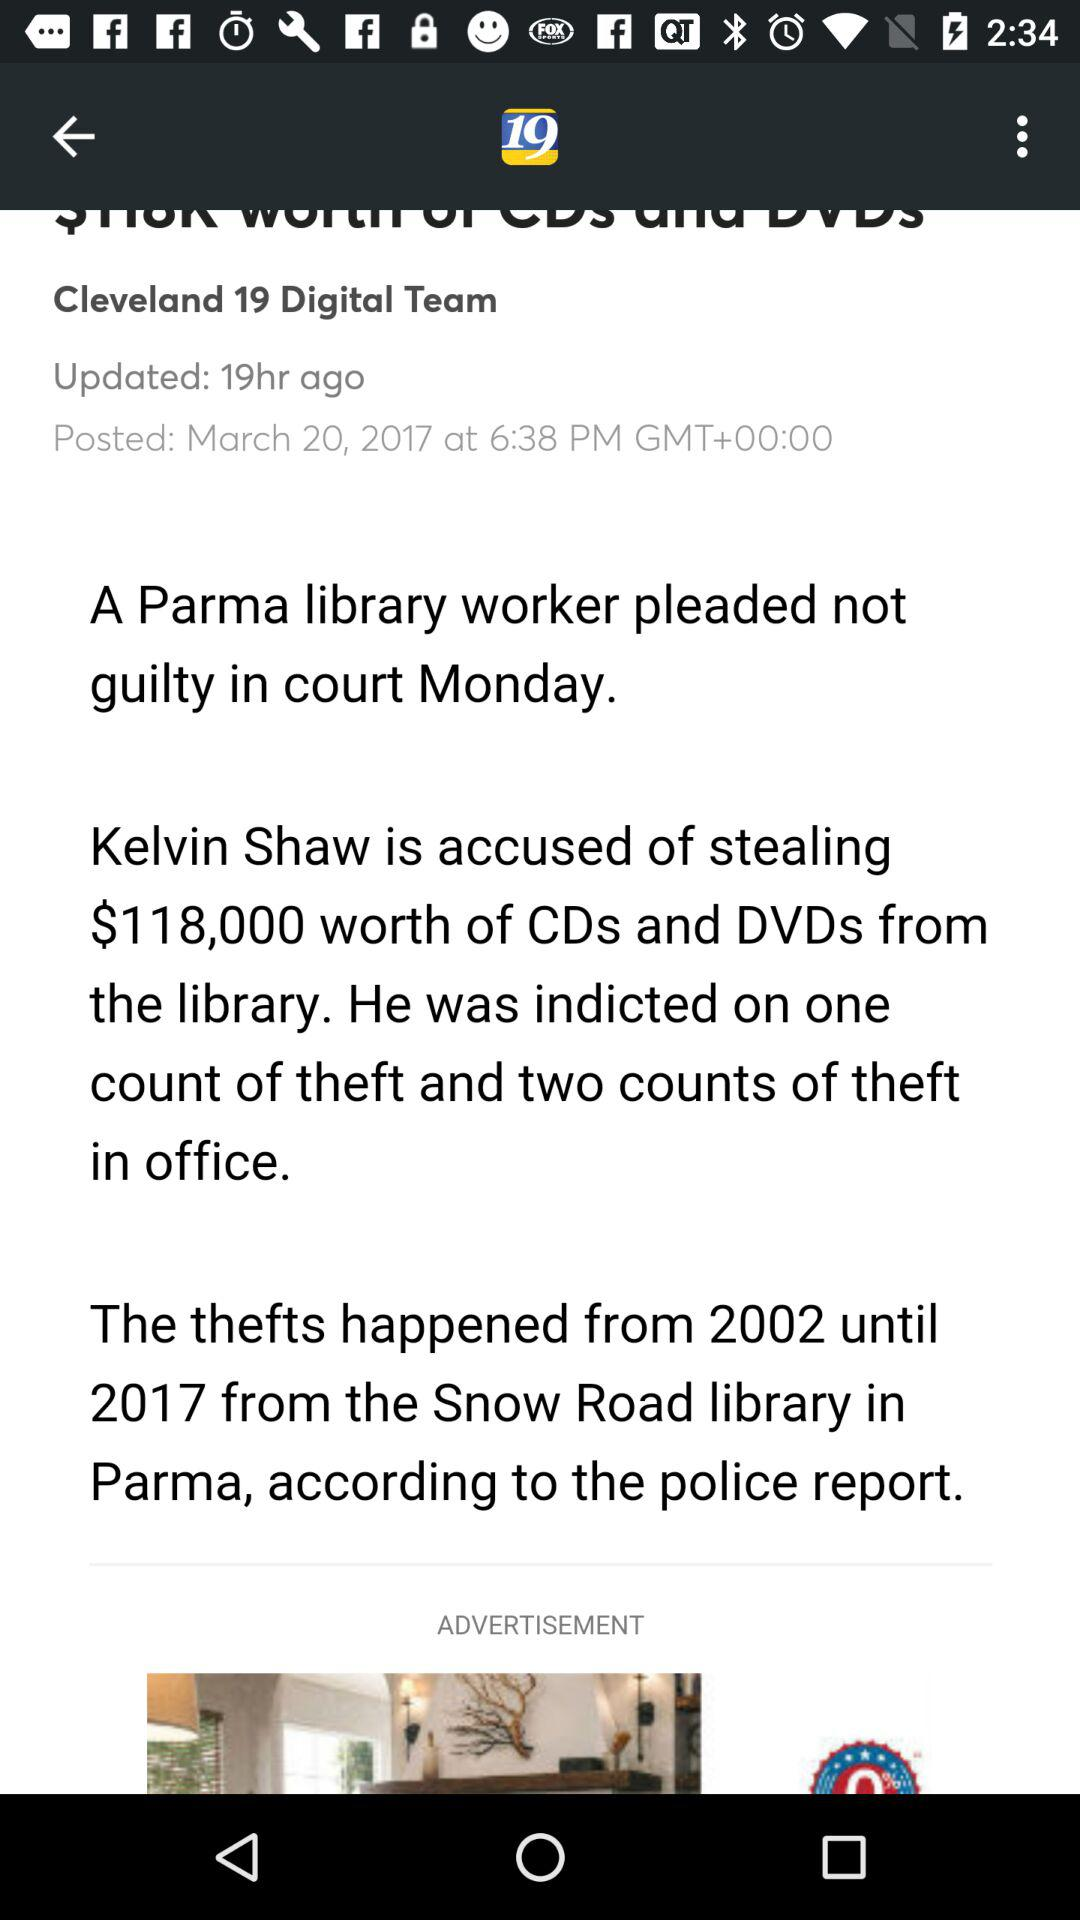Who is accused of stealing $118,000? The person who is accused of stealing $118,000 is Kelvin Shaw. 